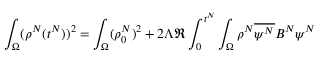Convert formula to latex. <formula><loc_0><loc_0><loc_500><loc_500>\int _ { \Omega } ( \rho ^ { N } ( t ^ { N } ) ) ^ { 2 } = \int _ { \Omega } ( \rho _ { 0 } ^ { N } ) ^ { 2 } + 2 \Lambda \Re \int _ { 0 } ^ { t ^ { N } } \int _ { \Omega } \rho ^ { N } \overline { { \psi ^ { N } } } B ^ { N } \psi ^ { N }</formula> 